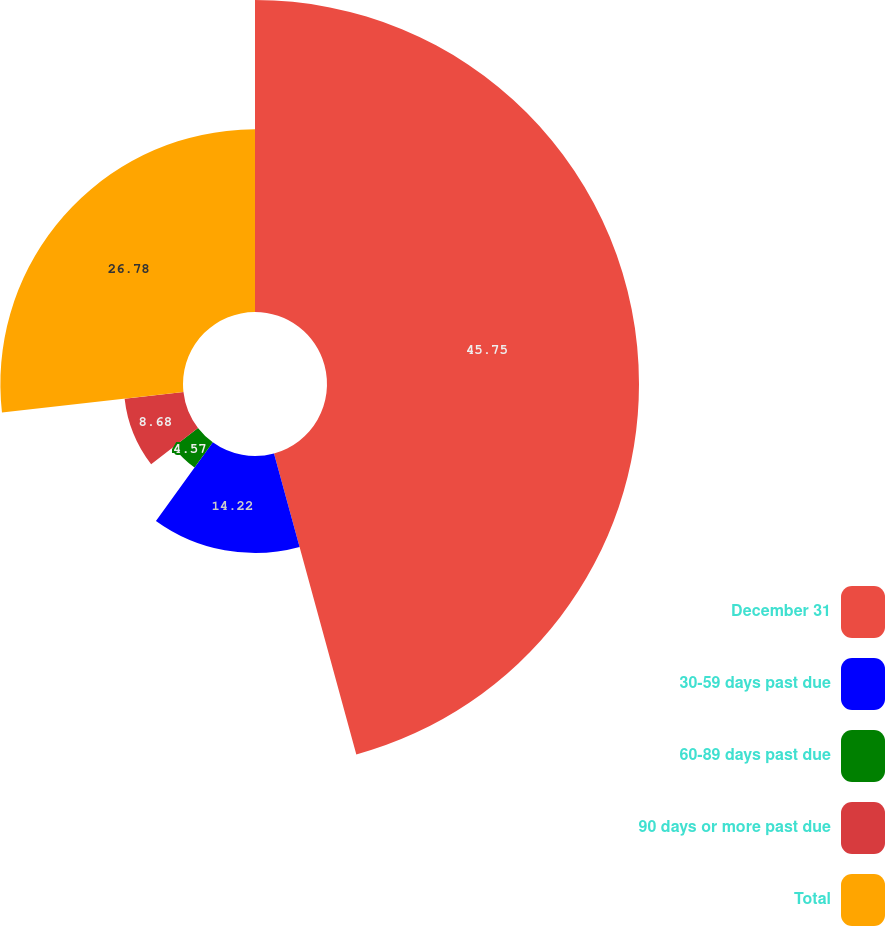Convert chart. <chart><loc_0><loc_0><loc_500><loc_500><pie_chart><fcel>December 31<fcel>30-59 days past due<fcel>60-89 days past due<fcel>90 days or more past due<fcel>Total<nl><fcel>45.75%<fcel>14.22%<fcel>4.57%<fcel>8.68%<fcel>26.78%<nl></chart> 